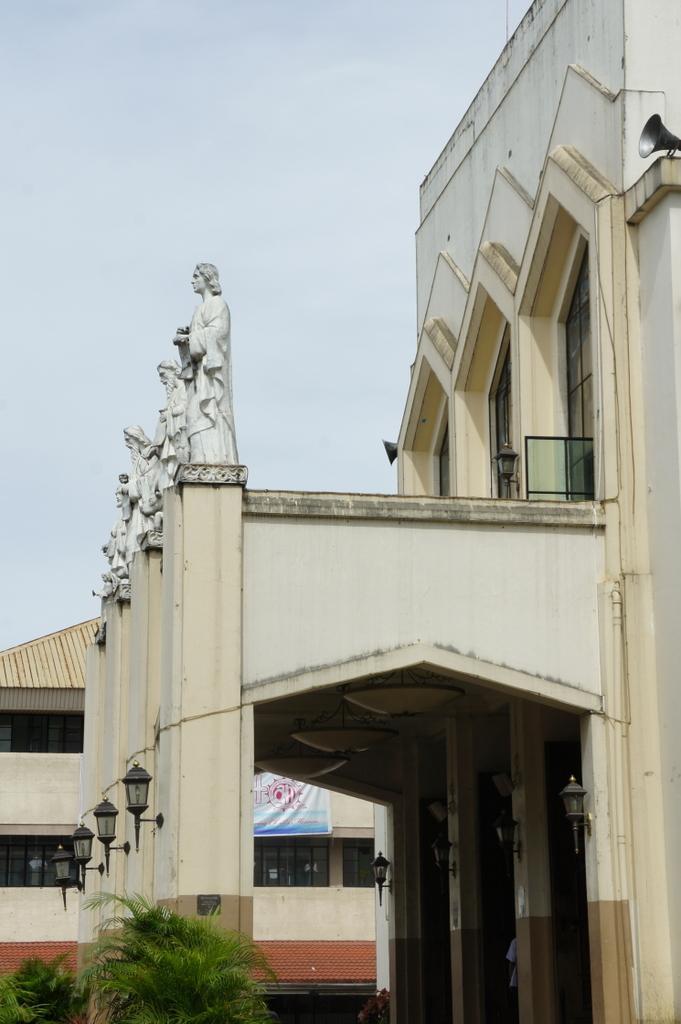Please provide a concise description of this image. In this picture there is a building and a speaker on the right side of the image and there are statues and lamps on the left side of the image, there are plants at the bottom side of the image and there is another building in the background area of the image. 